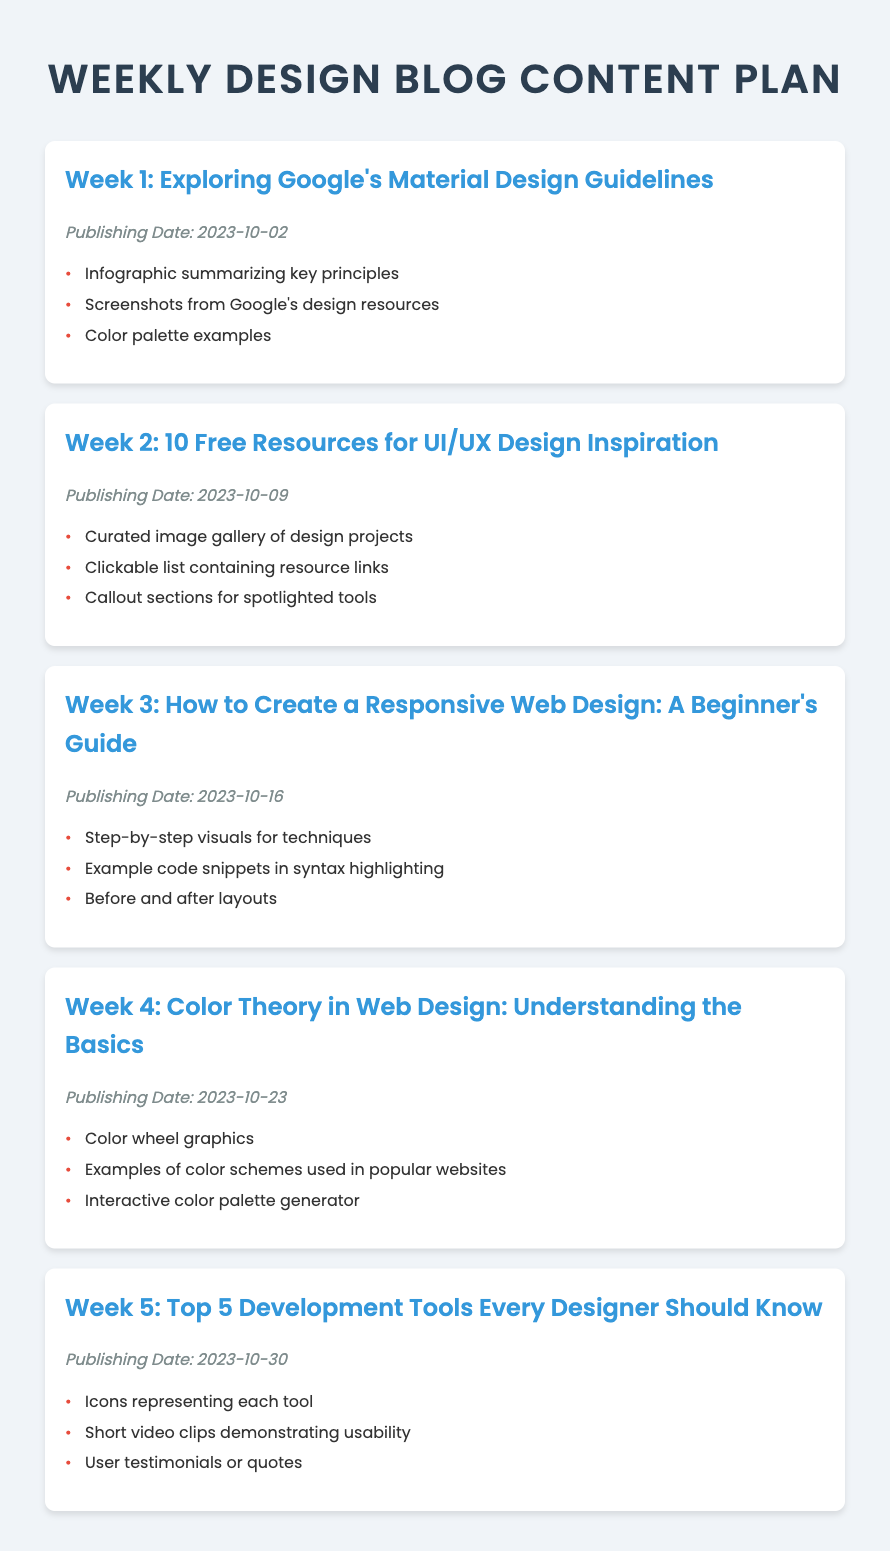What is the title of the document? The title of the document is specified in the head section of the HTML, which is "Weekly Design Blog Content Plan."
Answer: Weekly Design Blog Content Plan When is the first article scheduled to be published? The publishing date for the first article, found in the Week 1 section, is October 2, 2023.
Answer: 2023-10-02 How many design elements are listed for the article in Week 3? The article in Week 3 includes three design elements, as listed in the Week 3 section.
Answer: 3 What is the topic of the article for Week 4? The topic of the article for Week 4 is detailed in the heading for that week, which is "Color Theory in Web Design: Understanding the Basics."
Answer: Color Theory in Web Design: Understanding the Basics Which week discusses free resources for UI/UX design? The week that discusses free resources for UI/UX design is explicitly mentioned in the Week 2 section title.
Answer: Week 2 How is the body text styled in the document? The body text styling is defined in the CSS, where it states that the font is 'Poppins' and the color is dark gray (#333).
Answer: 'Poppins', dark gray What is the total number of articles planned for the month of October 2023? The document lists 5 articles, each scheduled for each week of October 2023.
Answer: 5 What color is used for the bullets in the list items? The color of the bullets in the list items is specified in the CSS as red (#e74c3c).
Answer: red Which week features an article about responsive web design? The week featuring the article about responsive web design is clearly indicated in the Week 3 section.
Answer: Week 3 